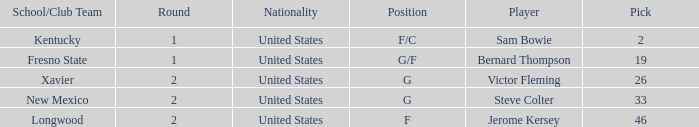What is the highest Pick, when Position is "G/F"? 19.0. 